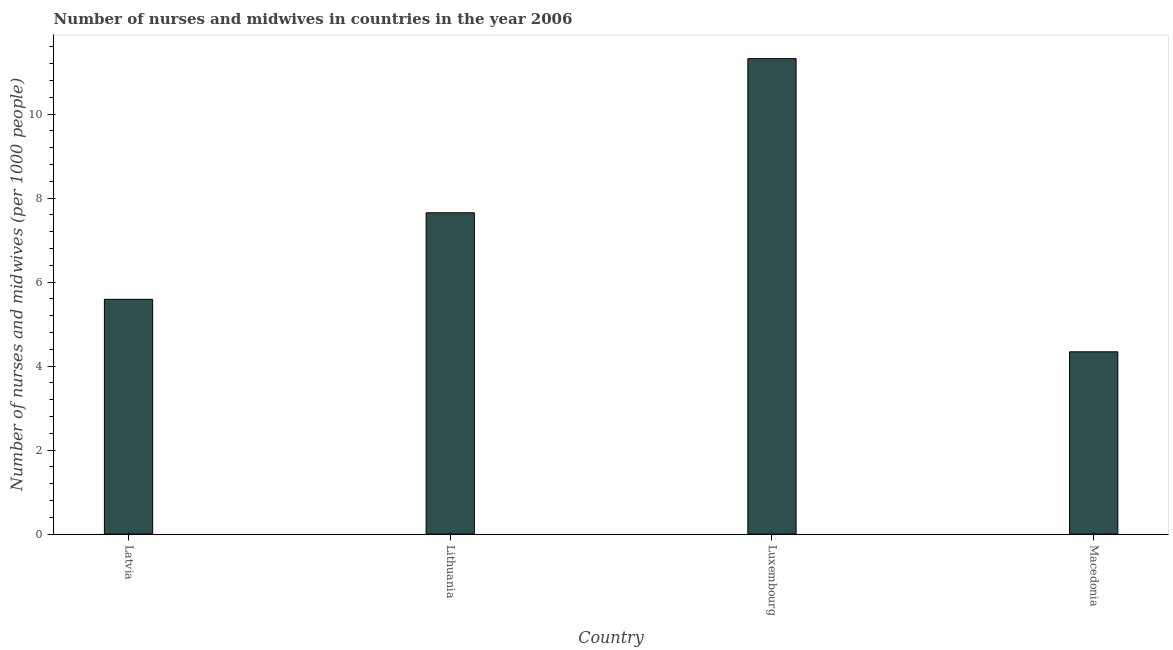Does the graph contain any zero values?
Your answer should be very brief. No. What is the title of the graph?
Ensure brevity in your answer.  Number of nurses and midwives in countries in the year 2006. What is the label or title of the X-axis?
Offer a very short reply. Country. What is the label or title of the Y-axis?
Your answer should be compact. Number of nurses and midwives (per 1000 people). What is the number of nurses and midwives in Lithuania?
Keep it short and to the point. 7.65. Across all countries, what is the maximum number of nurses and midwives?
Make the answer very short. 11.32. Across all countries, what is the minimum number of nurses and midwives?
Your response must be concise. 4.34. In which country was the number of nurses and midwives maximum?
Keep it short and to the point. Luxembourg. In which country was the number of nurses and midwives minimum?
Your answer should be very brief. Macedonia. What is the sum of the number of nurses and midwives?
Provide a succinct answer. 28.9. What is the difference between the number of nurses and midwives in Lithuania and Luxembourg?
Keep it short and to the point. -3.67. What is the average number of nurses and midwives per country?
Your response must be concise. 7.22. What is the median number of nurses and midwives?
Ensure brevity in your answer.  6.62. What is the ratio of the number of nurses and midwives in Lithuania to that in Macedonia?
Offer a very short reply. 1.76. What is the difference between the highest and the second highest number of nurses and midwives?
Give a very brief answer. 3.67. What is the difference between the highest and the lowest number of nurses and midwives?
Give a very brief answer. 6.98. In how many countries, is the number of nurses and midwives greater than the average number of nurses and midwives taken over all countries?
Your answer should be very brief. 2. How many bars are there?
Provide a short and direct response. 4. How many countries are there in the graph?
Give a very brief answer. 4. What is the Number of nurses and midwives (per 1000 people) in Latvia?
Offer a terse response. 5.59. What is the Number of nurses and midwives (per 1000 people) of Lithuania?
Your response must be concise. 7.65. What is the Number of nurses and midwives (per 1000 people) of Luxembourg?
Provide a succinct answer. 11.32. What is the Number of nurses and midwives (per 1000 people) of Macedonia?
Offer a very short reply. 4.34. What is the difference between the Number of nurses and midwives (per 1000 people) in Latvia and Lithuania?
Ensure brevity in your answer.  -2.06. What is the difference between the Number of nurses and midwives (per 1000 people) in Latvia and Luxembourg?
Give a very brief answer. -5.73. What is the difference between the Number of nurses and midwives (per 1000 people) in Latvia and Macedonia?
Keep it short and to the point. 1.25. What is the difference between the Number of nurses and midwives (per 1000 people) in Lithuania and Luxembourg?
Make the answer very short. -3.67. What is the difference between the Number of nurses and midwives (per 1000 people) in Lithuania and Macedonia?
Your answer should be compact. 3.31. What is the difference between the Number of nurses and midwives (per 1000 people) in Luxembourg and Macedonia?
Ensure brevity in your answer.  6.98. What is the ratio of the Number of nurses and midwives (per 1000 people) in Latvia to that in Lithuania?
Your response must be concise. 0.73. What is the ratio of the Number of nurses and midwives (per 1000 people) in Latvia to that in Luxembourg?
Make the answer very short. 0.49. What is the ratio of the Number of nurses and midwives (per 1000 people) in Latvia to that in Macedonia?
Your response must be concise. 1.29. What is the ratio of the Number of nurses and midwives (per 1000 people) in Lithuania to that in Luxembourg?
Your answer should be compact. 0.68. What is the ratio of the Number of nurses and midwives (per 1000 people) in Lithuania to that in Macedonia?
Provide a succinct answer. 1.76. What is the ratio of the Number of nurses and midwives (per 1000 people) in Luxembourg to that in Macedonia?
Provide a short and direct response. 2.61. 